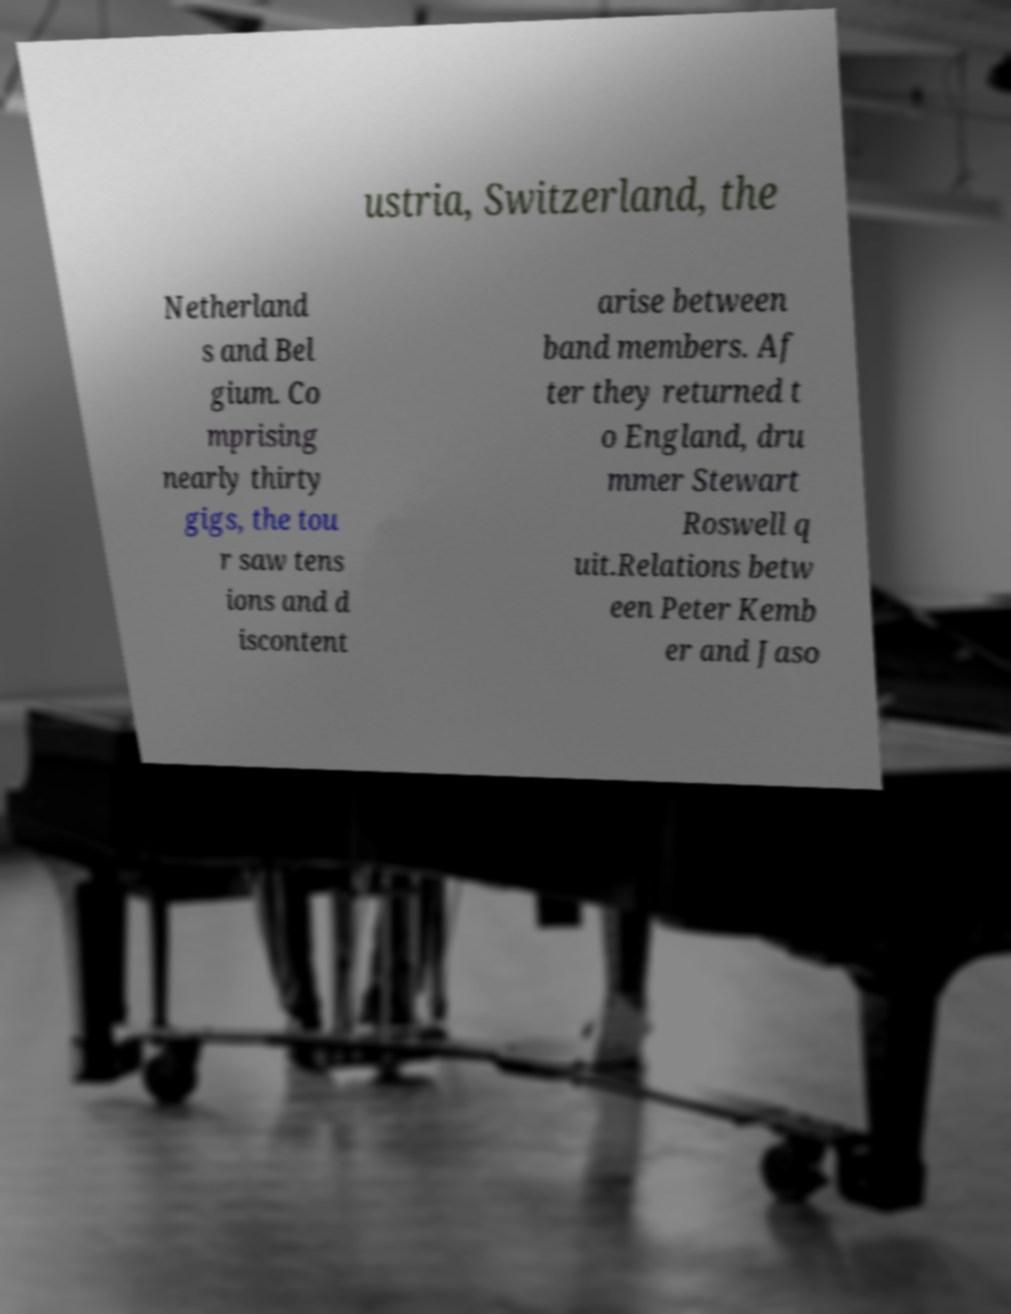Please read and relay the text visible in this image. What does it say? ustria, Switzerland, the Netherland s and Bel gium. Co mprising nearly thirty gigs, the tou r saw tens ions and d iscontent arise between band members. Af ter they returned t o England, dru mmer Stewart Roswell q uit.Relations betw een Peter Kemb er and Jaso 